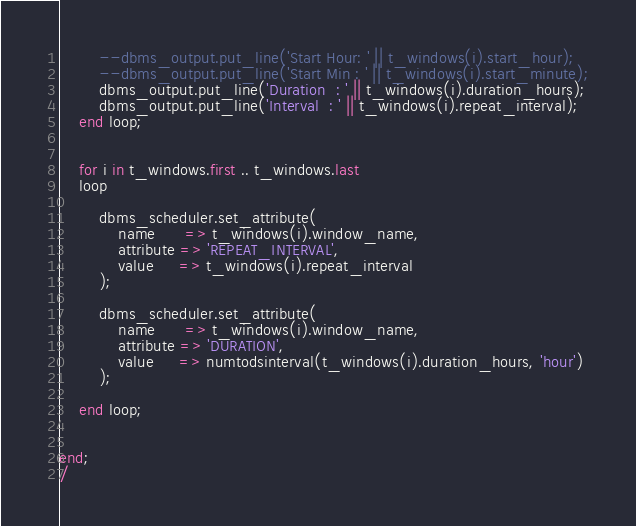Convert code to text. <code><loc_0><loc_0><loc_500><loc_500><_SQL_>		--dbms_output.put_line('Start Hour: ' || t_windows(i).start_hour);
		--dbms_output.put_line('Start Min : ' || t_windows(i).start_minute);
		dbms_output.put_line('Duration  : ' || t_windows(i).duration_hours);
		dbms_output.put_line('Interval  : ' || t_windows(i).repeat_interval);
	end loop;


	for i in t_windows.first .. t_windows.last
	loop

		dbms_scheduler.set_attribute(
			name      => t_windows(i).window_name,
			attribute => 'REPEAT_INTERVAL',
			value     => t_windows(i).repeat_interval
		);

		dbms_scheduler.set_attribute(
			name      => t_windows(i).window_name,
			attribute => 'DURATION',
			value     => numtodsinterval(t_windows(i).duration_hours, 'hour')
		);

	end loop;


end;
/

</code> 